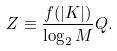<formula> <loc_0><loc_0><loc_500><loc_500>Z \equiv \frac { f ( | K | ) } { \log _ { 2 } M } Q .</formula> 